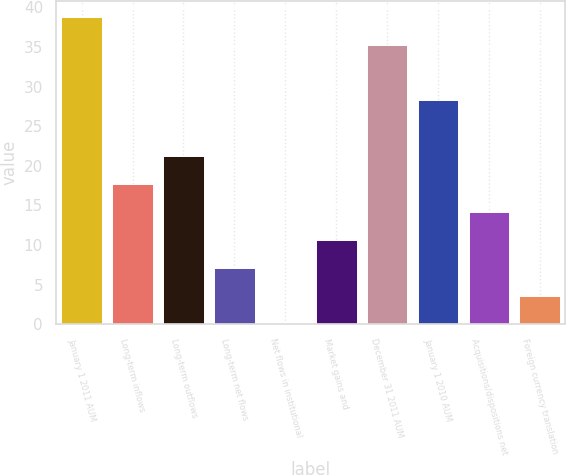Convert chart. <chart><loc_0><loc_0><loc_500><loc_500><bar_chart><fcel>January 1 2011 AUM<fcel>Long-term inflows<fcel>Long-term outflows<fcel>Long-term net flows<fcel>Net flows in institutional<fcel>Market gains and<fcel>December 31 2011 AUM<fcel>January 1 2010 AUM<fcel>Acquisitions/dispositions net<fcel>Foreign currency translation<nl><fcel>38.82<fcel>17.7<fcel>21.22<fcel>7.14<fcel>0.1<fcel>10.66<fcel>35.3<fcel>28.26<fcel>14.18<fcel>3.62<nl></chart> 